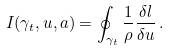Convert formula to latex. <formula><loc_0><loc_0><loc_500><loc_500>I ( { \gamma _ { t } } , u , a ) = \oint _ { \gamma _ { t } } \frac { 1 } { \rho } \frac { \delta l } { \delta u } \, .</formula> 